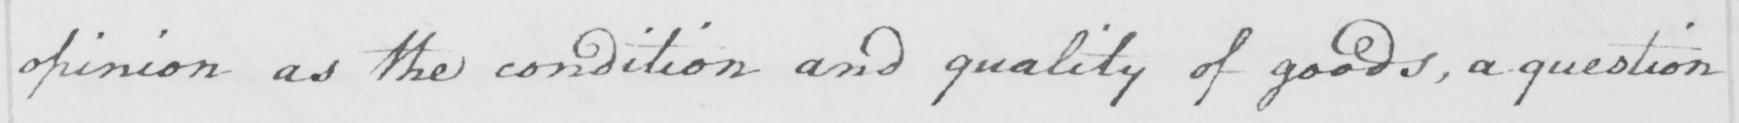Please provide the text content of this handwritten line. opinion as the condition and quality of goods , a question 